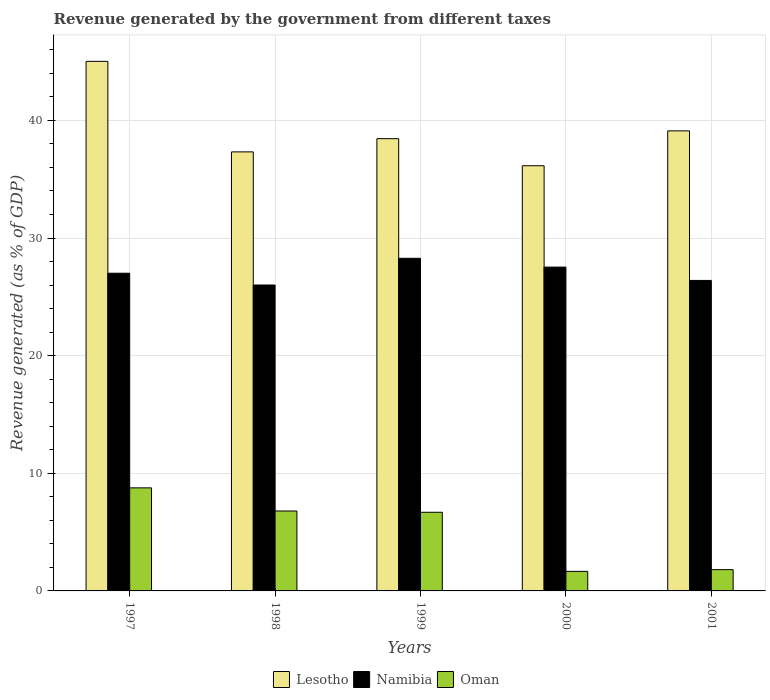How many groups of bars are there?
Provide a succinct answer. 5. Are the number of bars per tick equal to the number of legend labels?
Provide a succinct answer. Yes. How many bars are there on the 1st tick from the left?
Offer a terse response. 3. What is the label of the 5th group of bars from the left?
Offer a terse response. 2001. What is the revenue generated by the government in Lesotho in 2000?
Offer a terse response. 36.15. Across all years, what is the maximum revenue generated by the government in Namibia?
Your answer should be compact. 28.28. Across all years, what is the minimum revenue generated by the government in Oman?
Your response must be concise. 1.66. What is the total revenue generated by the government in Oman in the graph?
Your answer should be very brief. 25.72. What is the difference between the revenue generated by the government in Lesotho in 1997 and that in 1998?
Offer a very short reply. 7.7. What is the difference between the revenue generated by the government in Namibia in 2000 and the revenue generated by the government in Lesotho in 1998?
Provide a short and direct response. -9.8. What is the average revenue generated by the government in Lesotho per year?
Make the answer very short. 39.21. In the year 1998, what is the difference between the revenue generated by the government in Namibia and revenue generated by the government in Lesotho?
Ensure brevity in your answer.  -11.32. What is the ratio of the revenue generated by the government in Lesotho in 1997 to that in 1999?
Offer a terse response. 1.17. Is the revenue generated by the government in Lesotho in 2000 less than that in 2001?
Provide a succinct answer. Yes. What is the difference between the highest and the second highest revenue generated by the government in Namibia?
Your response must be concise. 0.75. What is the difference between the highest and the lowest revenue generated by the government in Lesotho?
Your answer should be compact. 8.87. In how many years, is the revenue generated by the government in Namibia greater than the average revenue generated by the government in Namibia taken over all years?
Provide a succinct answer. 2. What does the 2nd bar from the left in 1998 represents?
Provide a short and direct response. Namibia. What does the 1st bar from the right in 1999 represents?
Offer a terse response. Oman. Is it the case that in every year, the sum of the revenue generated by the government in Lesotho and revenue generated by the government in Namibia is greater than the revenue generated by the government in Oman?
Provide a succinct answer. Yes. How many bars are there?
Your answer should be compact. 15. Are all the bars in the graph horizontal?
Keep it short and to the point. No. How many years are there in the graph?
Ensure brevity in your answer.  5. What is the difference between two consecutive major ticks on the Y-axis?
Make the answer very short. 10. Are the values on the major ticks of Y-axis written in scientific E-notation?
Provide a short and direct response. No. Does the graph contain any zero values?
Provide a succinct answer. No. Where does the legend appear in the graph?
Provide a succinct answer. Bottom center. How are the legend labels stacked?
Make the answer very short. Horizontal. What is the title of the graph?
Your answer should be very brief. Revenue generated by the government from different taxes. What is the label or title of the Y-axis?
Provide a short and direct response. Revenue generated (as % of GDP). What is the Revenue generated (as % of GDP) in Lesotho in 1997?
Your answer should be compact. 45.02. What is the Revenue generated (as % of GDP) of Namibia in 1997?
Your answer should be compact. 27.01. What is the Revenue generated (as % of GDP) of Oman in 1997?
Give a very brief answer. 8.76. What is the Revenue generated (as % of GDP) of Lesotho in 1998?
Make the answer very short. 37.32. What is the Revenue generated (as % of GDP) of Namibia in 1998?
Ensure brevity in your answer.  26.01. What is the Revenue generated (as % of GDP) in Oman in 1998?
Offer a terse response. 6.79. What is the Revenue generated (as % of GDP) in Lesotho in 1999?
Your answer should be compact. 38.45. What is the Revenue generated (as % of GDP) of Namibia in 1999?
Give a very brief answer. 28.28. What is the Revenue generated (as % of GDP) of Oman in 1999?
Keep it short and to the point. 6.69. What is the Revenue generated (as % of GDP) of Lesotho in 2000?
Your response must be concise. 36.15. What is the Revenue generated (as % of GDP) in Namibia in 2000?
Keep it short and to the point. 27.53. What is the Revenue generated (as % of GDP) of Oman in 2000?
Give a very brief answer. 1.66. What is the Revenue generated (as % of GDP) of Lesotho in 2001?
Your answer should be very brief. 39.11. What is the Revenue generated (as % of GDP) in Namibia in 2001?
Your answer should be compact. 26.4. What is the Revenue generated (as % of GDP) in Oman in 2001?
Offer a very short reply. 1.81. Across all years, what is the maximum Revenue generated (as % of GDP) of Lesotho?
Give a very brief answer. 45.02. Across all years, what is the maximum Revenue generated (as % of GDP) in Namibia?
Your answer should be very brief. 28.28. Across all years, what is the maximum Revenue generated (as % of GDP) of Oman?
Offer a terse response. 8.76. Across all years, what is the minimum Revenue generated (as % of GDP) in Lesotho?
Your answer should be compact. 36.15. Across all years, what is the minimum Revenue generated (as % of GDP) in Namibia?
Provide a short and direct response. 26.01. Across all years, what is the minimum Revenue generated (as % of GDP) of Oman?
Ensure brevity in your answer.  1.66. What is the total Revenue generated (as % of GDP) of Lesotho in the graph?
Provide a succinct answer. 196.05. What is the total Revenue generated (as % of GDP) in Namibia in the graph?
Ensure brevity in your answer.  135.22. What is the total Revenue generated (as % of GDP) of Oman in the graph?
Make the answer very short. 25.72. What is the difference between the Revenue generated (as % of GDP) in Lesotho in 1997 and that in 1998?
Offer a very short reply. 7.7. What is the difference between the Revenue generated (as % of GDP) of Oman in 1997 and that in 1998?
Offer a very short reply. 1.97. What is the difference between the Revenue generated (as % of GDP) in Lesotho in 1997 and that in 1999?
Your response must be concise. 6.57. What is the difference between the Revenue generated (as % of GDP) in Namibia in 1997 and that in 1999?
Offer a very short reply. -1.27. What is the difference between the Revenue generated (as % of GDP) of Oman in 1997 and that in 1999?
Make the answer very short. 2.08. What is the difference between the Revenue generated (as % of GDP) in Lesotho in 1997 and that in 2000?
Provide a succinct answer. 8.87. What is the difference between the Revenue generated (as % of GDP) of Namibia in 1997 and that in 2000?
Make the answer very short. -0.52. What is the difference between the Revenue generated (as % of GDP) of Oman in 1997 and that in 2000?
Your answer should be compact. 7.1. What is the difference between the Revenue generated (as % of GDP) of Lesotho in 1997 and that in 2001?
Offer a terse response. 5.91. What is the difference between the Revenue generated (as % of GDP) of Namibia in 1997 and that in 2001?
Provide a short and direct response. 0.61. What is the difference between the Revenue generated (as % of GDP) of Oman in 1997 and that in 2001?
Your response must be concise. 6.95. What is the difference between the Revenue generated (as % of GDP) of Lesotho in 1998 and that in 1999?
Offer a terse response. -1.12. What is the difference between the Revenue generated (as % of GDP) of Namibia in 1998 and that in 1999?
Your response must be concise. -2.27. What is the difference between the Revenue generated (as % of GDP) of Oman in 1998 and that in 1999?
Your answer should be very brief. 0.11. What is the difference between the Revenue generated (as % of GDP) in Lesotho in 1998 and that in 2000?
Ensure brevity in your answer.  1.18. What is the difference between the Revenue generated (as % of GDP) in Namibia in 1998 and that in 2000?
Your answer should be compact. -1.52. What is the difference between the Revenue generated (as % of GDP) of Oman in 1998 and that in 2000?
Make the answer very short. 5.13. What is the difference between the Revenue generated (as % of GDP) in Lesotho in 1998 and that in 2001?
Your answer should be compact. -1.79. What is the difference between the Revenue generated (as % of GDP) of Namibia in 1998 and that in 2001?
Ensure brevity in your answer.  -0.39. What is the difference between the Revenue generated (as % of GDP) of Oman in 1998 and that in 2001?
Offer a very short reply. 4.99. What is the difference between the Revenue generated (as % of GDP) in Lesotho in 1999 and that in 2000?
Give a very brief answer. 2.3. What is the difference between the Revenue generated (as % of GDP) of Namibia in 1999 and that in 2000?
Offer a very short reply. 0.75. What is the difference between the Revenue generated (as % of GDP) in Oman in 1999 and that in 2000?
Your answer should be very brief. 5.02. What is the difference between the Revenue generated (as % of GDP) of Lesotho in 1999 and that in 2001?
Your response must be concise. -0.66. What is the difference between the Revenue generated (as % of GDP) of Namibia in 1999 and that in 2001?
Your response must be concise. 1.88. What is the difference between the Revenue generated (as % of GDP) in Oman in 1999 and that in 2001?
Your answer should be compact. 4.88. What is the difference between the Revenue generated (as % of GDP) of Lesotho in 2000 and that in 2001?
Offer a very short reply. -2.96. What is the difference between the Revenue generated (as % of GDP) in Namibia in 2000 and that in 2001?
Offer a terse response. 1.13. What is the difference between the Revenue generated (as % of GDP) in Oman in 2000 and that in 2001?
Provide a short and direct response. -0.15. What is the difference between the Revenue generated (as % of GDP) of Lesotho in 1997 and the Revenue generated (as % of GDP) of Namibia in 1998?
Provide a succinct answer. 19.01. What is the difference between the Revenue generated (as % of GDP) in Lesotho in 1997 and the Revenue generated (as % of GDP) in Oman in 1998?
Ensure brevity in your answer.  38.23. What is the difference between the Revenue generated (as % of GDP) in Namibia in 1997 and the Revenue generated (as % of GDP) in Oman in 1998?
Offer a very short reply. 20.21. What is the difference between the Revenue generated (as % of GDP) in Lesotho in 1997 and the Revenue generated (as % of GDP) in Namibia in 1999?
Offer a very short reply. 16.74. What is the difference between the Revenue generated (as % of GDP) of Lesotho in 1997 and the Revenue generated (as % of GDP) of Oman in 1999?
Ensure brevity in your answer.  38.33. What is the difference between the Revenue generated (as % of GDP) in Namibia in 1997 and the Revenue generated (as % of GDP) in Oman in 1999?
Offer a terse response. 20.32. What is the difference between the Revenue generated (as % of GDP) of Lesotho in 1997 and the Revenue generated (as % of GDP) of Namibia in 2000?
Your answer should be very brief. 17.49. What is the difference between the Revenue generated (as % of GDP) in Lesotho in 1997 and the Revenue generated (as % of GDP) in Oman in 2000?
Your response must be concise. 43.36. What is the difference between the Revenue generated (as % of GDP) in Namibia in 1997 and the Revenue generated (as % of GDP) in Oman in 2000?
Provide a short and direct response. 25.35. What is the difference between the Revenue generated (as % of GDP) of Lesotho in 1997 and the Revenue generated (as % of GDP) of Namibia in 2001?
Provide a succinct answer. 18.62. What is the difference between the Revenue generated (as % of GDP) in Lesotho in 1997 and the Revenue generated (as % of GDP) in Oman in 2001?
Your answer should be very brief. 43.21. What is the difference between the Revenue generated (as % of GDP) of Namibia in 1997 and the Revenue generated (as % of GDP) of Oman in 2001?
Give a very brief answer. 25.2. What is the difference between the Revenue generated (as % of GDP) in Lesotho in 1998 and the Revenue generated (as % of GDP) in Namibia in 1999?
Your answer should be compact. 9.05. What is the difference between the Revenue generated (as % of GDP) of Lesotho in 1998 and the Revenue generated (as % of GDP) of Oman in 1999?
Provide a short and direct response. 30.64. What is the difference between the Revenue generated (as % of GDP) in Namibia in 1998 and the Revenue generated (as % of GDP) in Oman in 1999?
Your answer should be compact. 19.32. What is the difference between the Revenue generated (as % of GDP) of Lesotho in 1998 and the Revenue generated (as % of GDP) of Namibia in 2000?
Your answer should be very brief. 9.8. What is the difference between the Revenue generated (as % of GDP) of Lesotho in 1998 and the Revenue generated (as % of GDP) of Oman in 2000?
Your answer should be compact. 35.66. What is the difference between the Revenue generated (as % of GDP) in Namibia in 1998 and the Revenue generated (as % of GDP) in Oman in 2000?
Offer a terse response. 24.34. What is the difference between the Revenue generated (as % of GDP) in Lesotho in 1998 and the Revenue generated (as % of GDP) in Namibia in 2001?
Your answer should be very brief. 10.93. What is the difference between the Revenue generated (as % of GDP) of Lesotho in 1998 and the Revenue generated (as % of GDP) of Oman in 2001?
Offer a very short reply. 35.52. What is the difference between the Revenue generated (as % of GDP) of Namibia in 1998 and the Revenue generated (as % of GDP) of Oman in 2001?
Give a very brief answer. 24.2. What is the difference between the Revenue generated (as % of GDP) in Lesotho in 1999 and the Revenue generated (as % of GDP) in Namibia in 2000?
Ensure brevity in your answer.  10.92. What is the difference between the Revenue generated (as % of GDP) in Lesotho in 1999 and the Revenue generated (as % of GDP) in Oman in 2000?
Provide a succinct answer. 36.79. What is the difference between the Revenue generated (as % of GDP) of Namibia in 1999 and the Revenue generated (as % of GDP) of Oman in 2000?
Offer a very short reply. 26.62. What is the difference between the Revenue generated (as % of GDP) of Lesotho in 1999 and the Revenue generated (as % of GDP) of Namibia in 2001?
Your answer should be very brief. 12.05. What is the difference between the Revenue generated (as % of GDP) of Lesotho in 1999 and the Revenue generated (as % of GDP) of Oman in 2001?
Provide a succinct answer. 36.64. What is the difference between the Revenue generated (as % of GDP) in Namibia in 1999 and the Revenue generated (as % of GDP) in Oman in 2001?
Your response must be concise. 26.47. What is the difference between the Revenue generated (as % of GDP) in Lesotho in 2000 and the Revenue generated (as % of GDP) in Namibia in 2001?
Keep it short and to the point. 9.75. What is the difference between the Revenue generated (as % of GDP) of Lesotho in 2000 and the Revenue generated (as % of GDP) of Oman in 2001?
Your answer should be compact. 34.34. What is the difference between the Revenue generated (as % of GDP) in Namibia in 2000 and the Revenue generated (as % of GDP) in Oman in 2001?
Ensure brevity in your answer.  25.72. What is the average Revenue generated (as % of GDP) in Lesotho per year?
Keep it short and to the point. 39.21. What is the average Revenue generated (as % of GDP) in Namibia per year?
Your answer should be compact. 27.04. What is the average Revenue generated (as % of GDP) in Oman per year?
Your answer should be compact. 5.14. In the year 1997, what is the difference between the Revenue generated (as % of GDP) in Lesotho and Revenue generated (as % of GDP) in Namibia?
Provide a short and direct response. 18.01. In the year 1997, what is the difference between the Revenue generated (as % of GDP) in Lesotho and Revenue generated (as % of GDP) in Oman?
Your response must be concise. 36.26. In the year 1997, what is the difference between the Revenue generated (as % of GDP) in Namibia and Revenue generated (as % of GDP) in Oman?
Provide a short and direct response. 18.25. In the year 1998, what is the difference between the Revenue generated (as % of GDP) in Lesotho and Revenue generated (as % of GDP) in Namibia?
Your response must be concise. 11.32. In the year 1998, what is the difference between the Revenue generated (as % of GDP) of Lesotho and Revenue generated (as % of GDP) of Oman?
Give a very brief answer. 30.53. In the year 1998, what is the difference between the Revenue generated (as % of GDP) of Namibia and Revenue generated (as % of GDP) of Oman?
Provide a short and direct response. 19.21. In the year 1999, what is the difference between the Revenue generated (as % of GDP) in Lesotho and Revenue generated (as % of GDP) in Namibia?
Your answer should be compact. 10.17. In the year 1999, what is the difference between the Revenue generated (as % of GDP) of Lesotho and Revenue generated (as % of GDP) of Oman?
Provide a short and direct response. 31.76. In the year 1999, what is the difference between the Revenue generated (as % of GDP) in Namibia and Revenue generated (as % of GDP) in Oman?
Offer a terse response. 21.59. In the year 2000, what is the difference between the Revenue generated (as % of GDP) of Lesotho and Revenue generated (as % of GDP) of Namibia?
Make the answer very short. 8.62. In the year 2000, what is the difference between the Revenue generated (as % of GDP) in Lesotho and Revenue generated (as % of GDP) in Oman?
Give a very brief answer. 34.48. In the year 2000, what is the difference between the Revenue generated (as % of GDP) in Namibia and Revenue generated (as % of GDP) in Oman?
Ensure brevity in your answer.  25.87. In the year 2001, what is the difference between the Revenue generated (as % of GDP) of Lesotho and Revenue generated (as % of GDP) of Namibia?
Make the answer very short. 12.72. In the year 2001, what is the difference between the Revenue generated (as % of GDP) of Lesotho and Revenue generated (as % of GDP) of Oman?
Ensure brevity in your answer.  37.3. In the year 2001, what is the difference between the Revenue generated (as % of GDP) of Namibia and Revenue generated (as % of GDP) of Oman?
Offer a terse response. 24.59. What is the ratio of the Revenue generated (as % of GDP) of Lesotho in 1997 to that in 1998?
Offer a very short reply. 1.21. What is the ratio of the Revenue generated (as % of GDP) of Oman in 1997 to that in 1998?
Provide a short and direct response. 1.29. What is the ratio of the Revenue generated (as % of GDP) of Lesotho in 1997 to that in 1999?
Your answer should be compact. 1.17. What is the ratio of the Revenue generated (as % of GDP) of Namibia in 1997 to that in 1999?
Ensure brevity in your answer.  0.96. What is the ratio of the Revenue generated (as % of GDP) of Oman in 1997 to that in 1999?
Offer a terse response. 1.31. What is the ratio of the Revenue generated (as % of GDP) of Lesotho in 1997 to that in 2000?
Your answer should be compact. 1.25. What is the ratio of the Revenue generated (as % of GDP) of Namibia in 1997 to that in 2000?
Give a very brief answer. 0.98. What is the ratio of the Revenue generated (as % of GDP) in Oman in 1997 to that in 2000?
Provide a succinct answer. 5.27. What is the ratio of the Revenue generated (as % of GDP) of Lesotho in 1997 to that in 2001?
Make the answer very short. 1.15. What is the ratio of the Revenue generated (as % of GDP) of Namibia in 1997 to that in 2001?
Ensure brevity in your answer.  1.02. What is the ratio of the Revenue generated (as % of GDP) of Oman in 1997 to that in 2001?
Provide a succinct answer. 4.84. What is the ratio of the Revenue generated (as % of GDP) in Lesotho in 1998 to that in 1999?
Provide a succinct answer. 0.97. What is the ratio of the Revenue generated (as % of GDP) in Namibia in 1998 to that in 1999?
Give a very brief answer. 0.92. What is the ratio of the Revenue generated (as % of GDP) of Oman in 1998 to that in 1999?
Ensure brevity in your answer.  1.02. What is the ratio of the Revenue generated (as % of GDP) of Lesotho in 1998 to that in 2000?
Make the answer very short. 1.03. What is the ratio of the Revenue generated (as % of GDP) of Namibia in 1998 to that in 2000?
Provide a succinct answer. 0.94. What is the ratio of the Revenue generated (as % of GDP) of Oman in 1998 to that in 2000?
Offer a terse response. 4.09. What is the ratio of the Revenue generated (as % of GDP) in Lesotho in 1998 to that in 2001?
Offer a terse response. 0.95. What is the ratio of the Revenue generated (as % of GDP) of Oman in 1998 to that in 2001?
Keep it short and to the point. 3.76. What is the ratio of the Revenue generated (as % of GDP) of Lesotho in 1999 to that in 2000?
Offer a very short reply. 1.06. What is the ratio of the Revenue generated (as % of GDP) of Namibia in 1999 to that in 2000?
Your answer should be very brief. 1.03. What is the ratio of the Revenue generated (as % of GDP) in Oman in 1999 to that in 2000?
Your response must be concise. 4.02. What is the ratio of the Revenue generated (as % of GDP) of Lesotho in 1999 to that in 2001?
Ensure brevity in your answer.  0.98. What is the ratio of the Revenue generated (as % of GDP) of Namibia in 1999 to that in 2001?
Your response must be concise. 1.07. What is the ratio of the Revenue generated (as % of GDP) in Oman in 1999 to that in 2001?
Make the answer very short. 3.7. What is the ratio of the Revenue generated (as % of GDP) of Lesotho in 2000 to that in 2001?
Provide a succinct answer. 0.92. What is the ratio of the Revenue generated (as % of GDP) in Namibia in 2000 to that in 2001?
Offer a very short reply. 1.04. What is the ratio of the Revenue generated (as % of GDP) of Oman in 2000 to that in 2001?
Provide a short and direct response. 0.92. What is the difference between the highest and the second highest Revenue generated (as % of GDP) in Lesotho?
Your answer should be very brief. 5.91. What is the difference between the highest and the second highest Revenue generated (as % of GDP) in Namibia?
Offer a terse response. 0.75. What is the difference between the highest and the second highest Revenue generated (as % of GDP) in Oman?
Make the answer very short. 1.97. What is the difference between the highest and the lowest Revenue generated (as % of GDP) of Lesotho?
Your answer should be very brief. 8.87. What is the difference between the highest and the lowest Revenue generated (as % of GDP) of Namibia?
Provide a short and direct response. 2.27. What is the difference between the highest and the lowest Revenue generated (as % of GDP) of Oman?
Offer a very short reply. 7.1. 